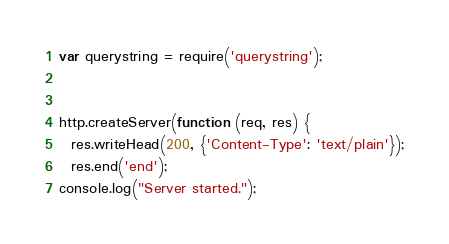<code> <loc_0><loc_0><loc_500><loc_500><_JavaScript_>var querystring = require('querystring');


http.createServer(function (req, res) {
  res.writeHead(200, {'Content-Type': 'text/plain'});
  res.end('end');
console.log("Server started.");</code> 